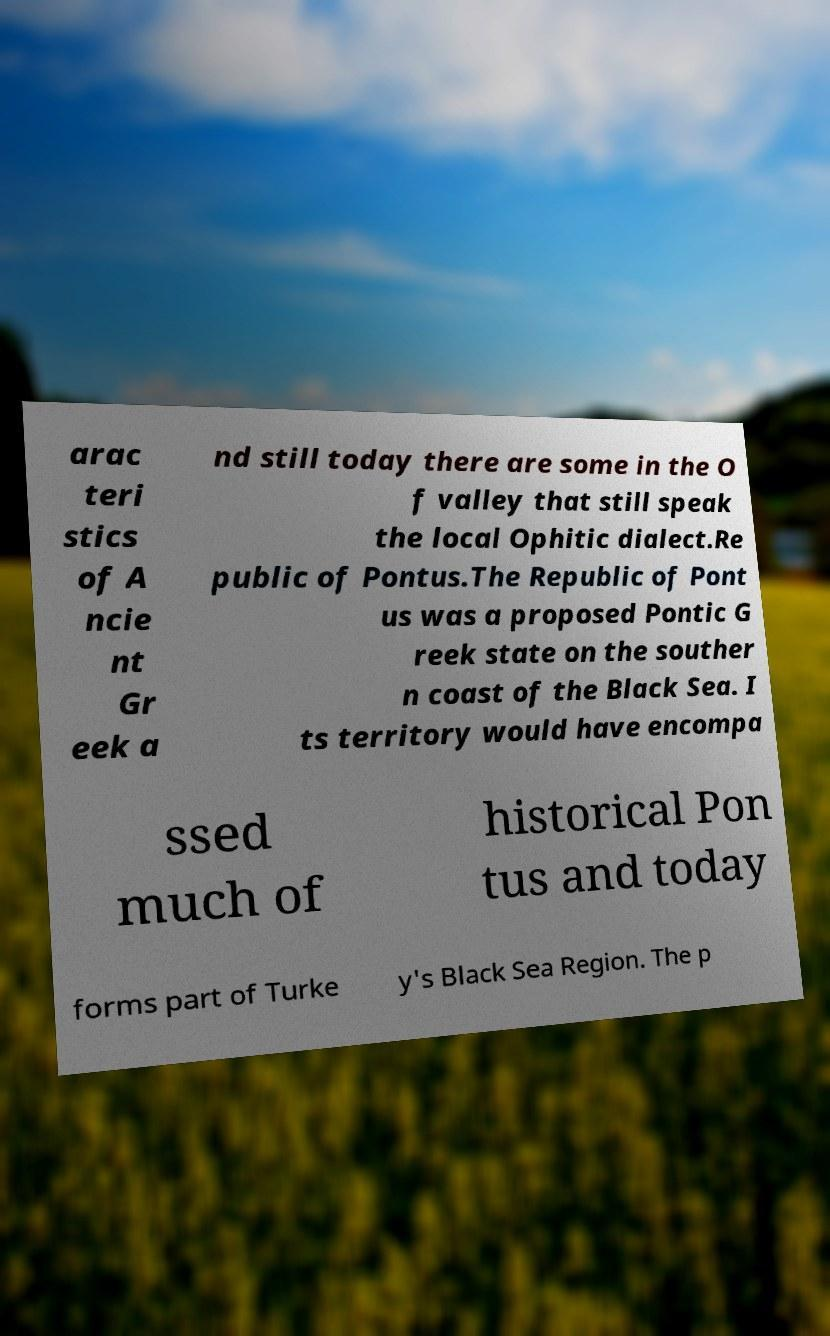Please read and relay the text visible in this image. What does it say? arac teri stics of A ncie nt Gr eek a nd still today there are some in the O f valley that still speak the local Ophitic dialect.Re public of Pontus.The Republic of Pont us was a proposed Pontic G reek state on the souther n coast of the Black Sea. I ts territory would have encompa ssed much of historical Pon tus and today forms part of Turke y's Black Sea Region. The p 